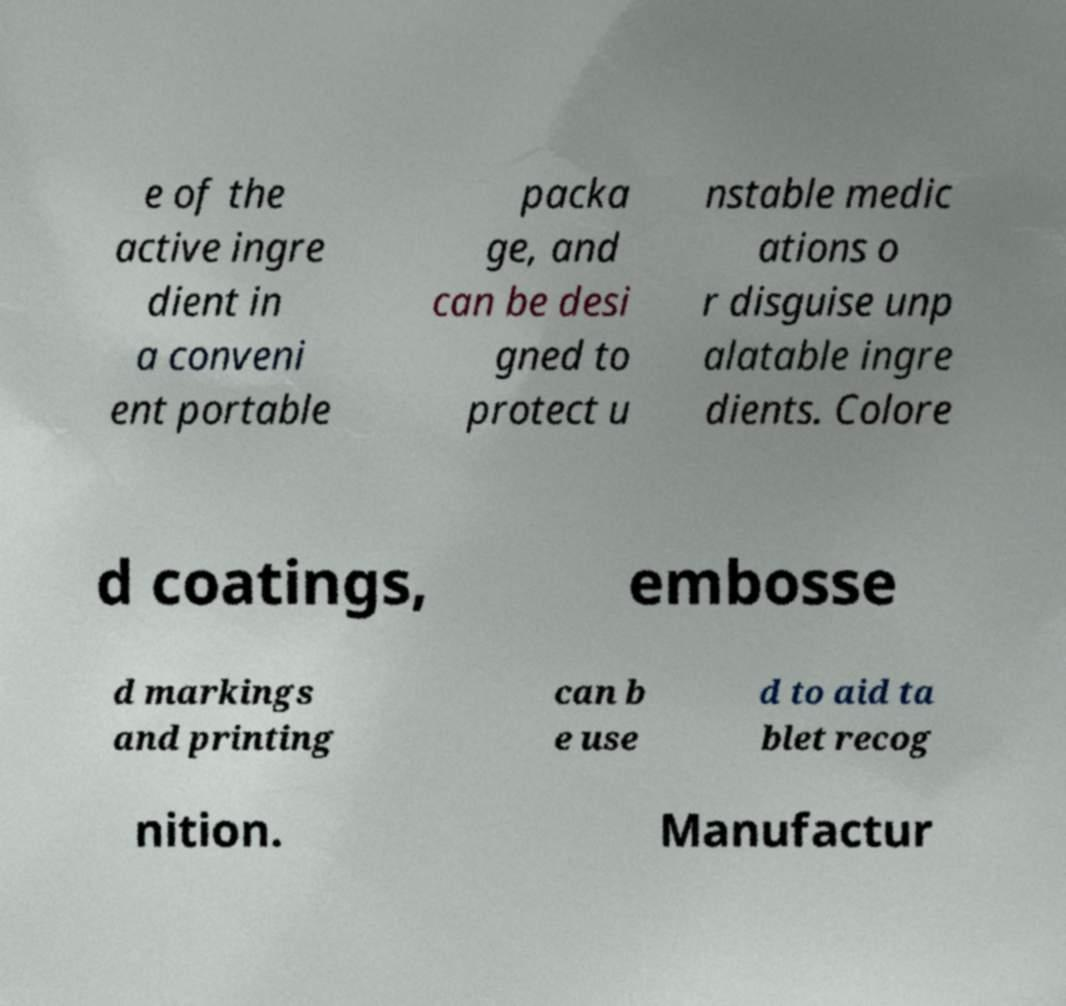There's text embedded in this image that I need extracted. Can you transcribe it verbatim? e of the active ingre dient in a conveni ent portable packa ge, and can be desi gned to protect u nstable medic ations o r disguise unp alatable ingre dients. Colore d coatings, embosse d markings and printing can b e use d to aid ta blet recog nition. Manufactur 